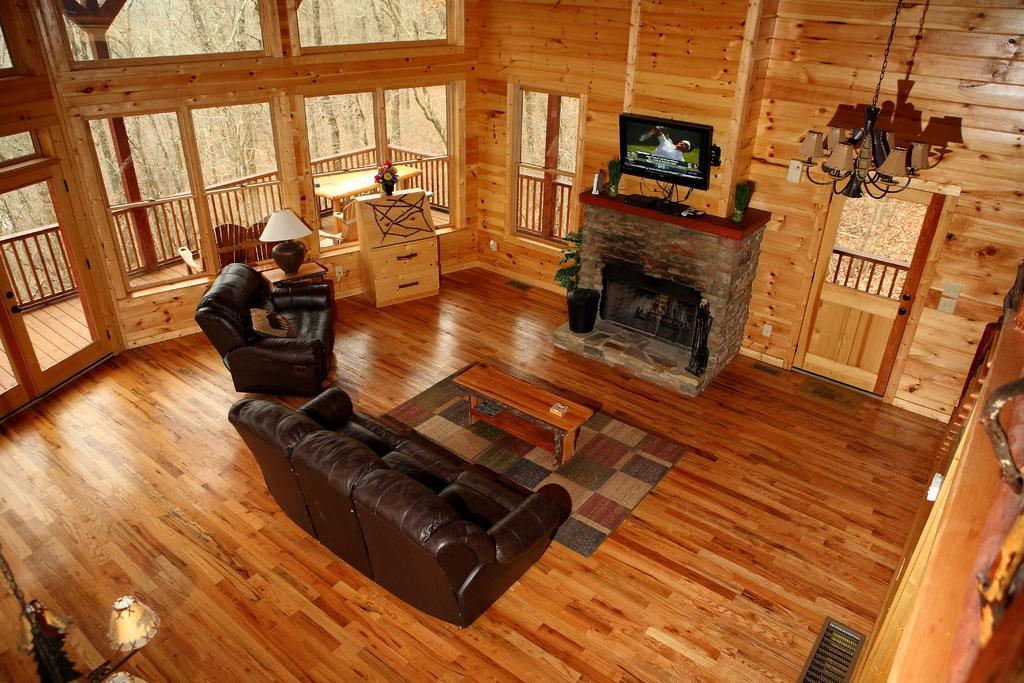What type of space is depicted in the image? There is a room in the image. What furniture is present in the room? There is a couch in the room. Are there any light sources in the room? Yes, there is a lamp in the room. What type of entertainment device is in the room? There is a television in the room. What decorative item can be seen on a table in the room? There is a flower vase on a table in the room. What type of hammer is being used by the laborer in the image? There is no hammer or laborer present in the image. How many light bulbs are visible in the lamp in the image? The image does not show the inside of the lamp, so it is not possible to determine the number of light bulbs. 